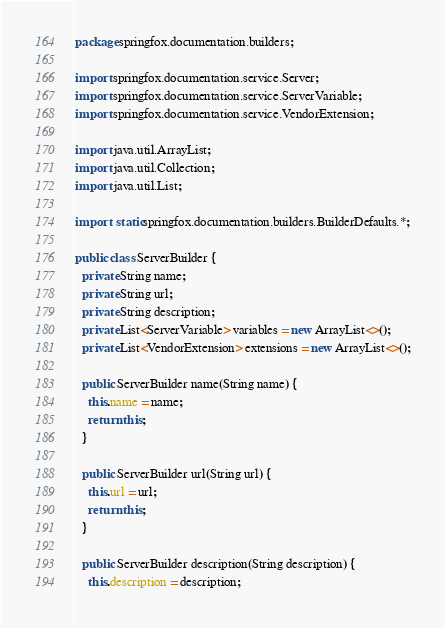Convert code to text. <code><loc_0><loc_0><loc_500><loc_500><_Java_>package springfox.documentation.builders;

import springfox.documentation.service.Server;
import springfox.documentation.service.ServerVariable;
import springfox.documentation.service.VendorExtension;

import java.util.ArrayList;
import java.util.Collection;
import java.util.List;

import static springfox.documentation.builders.BuilderDefaults.*;

public class ServerBuilder {
  private String name;
  private String url;
  private String description;
  private List<ServerVariable> variables = new ArrayList<>();
  private List<VendorExtension> extensions = new ArrayList<>();

  public ServerBuilder name(String name) {
    this.name = name;
    return this;
  }

  public ServerBuilder url(String url) {
    this.url = url;
    return this;
  }

  public ServerBuilder description(String description) {
    this.description = description;</code> 